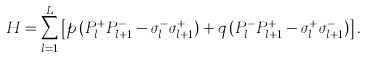Convert formula to latex. <formula><loc_0><loc_0><loc_500><loc_500>H = \sum _ { l = 1 } ^ { L } \left [ p \, ( P _ { l } ^ { + } P _ { l + 1 } ^ { - } - \sigma _ { l } ^ { - } \sigma _ { l + 1 } ^ { + } ) + q \, ( P _ { l } ^ { - } P _ { l + 1 } ^ { + } - \sigma _ { l } ^ { + } \sigma _ { l + 1 } ^ { - } ) \right ] .</formula> 